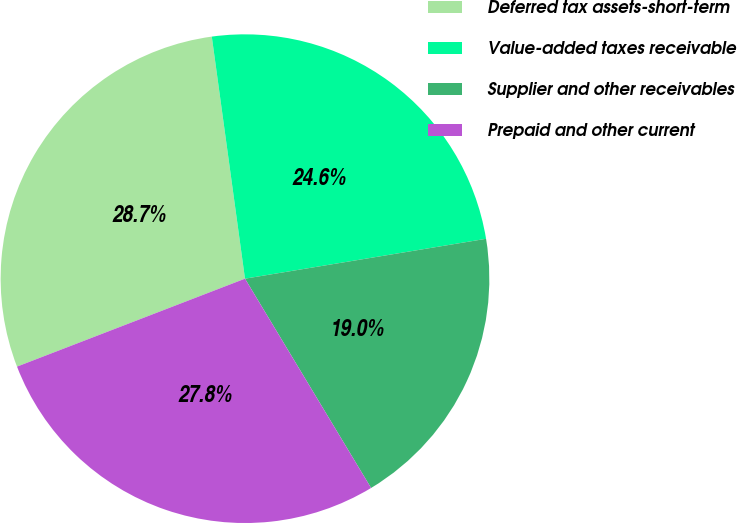<chart> <loc_0><loc_0><loc_500><loc_500><pie_chart><fcel>Deferred tax assets-short-term<fcel>Value-added taxes receivable<fcel>Supplier and other receivables<fcel>Prepaid and other current<nl><fcel>28.69%<fcel>24.56%<fcel>18.98%<fcel>27.77%<nl></chart> 